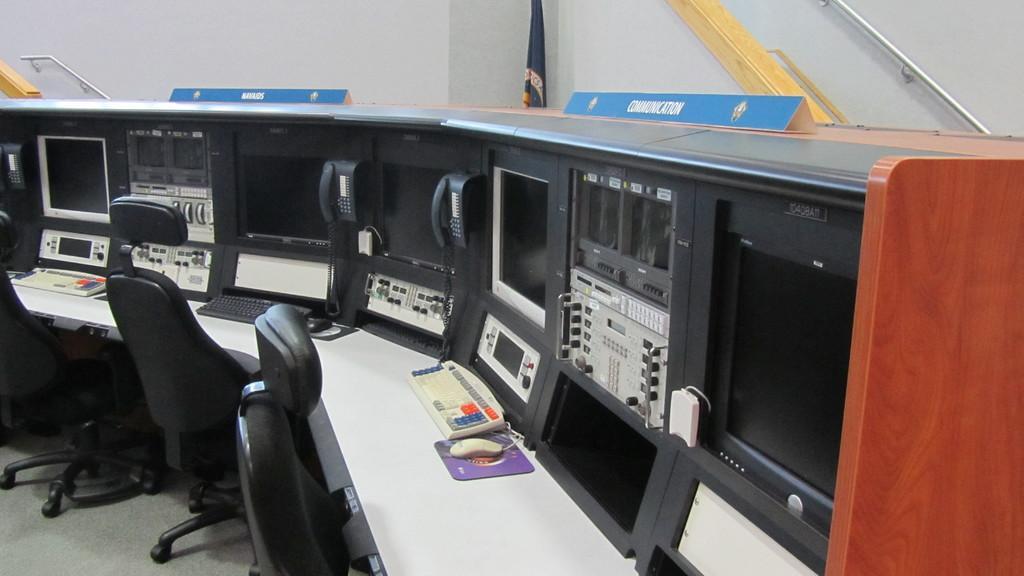Please provide a concise description of this image. In this image I can see a desk which is white in color and on the desk I can see a mouse, a mouse pad and few keyboards which are black and white in color and I can see few telephones, few monitors and few other electronic equipment and I can see few chairs in front of the desk. In the background I can see a white colored wall, a flag and few boards which are blue in color. 